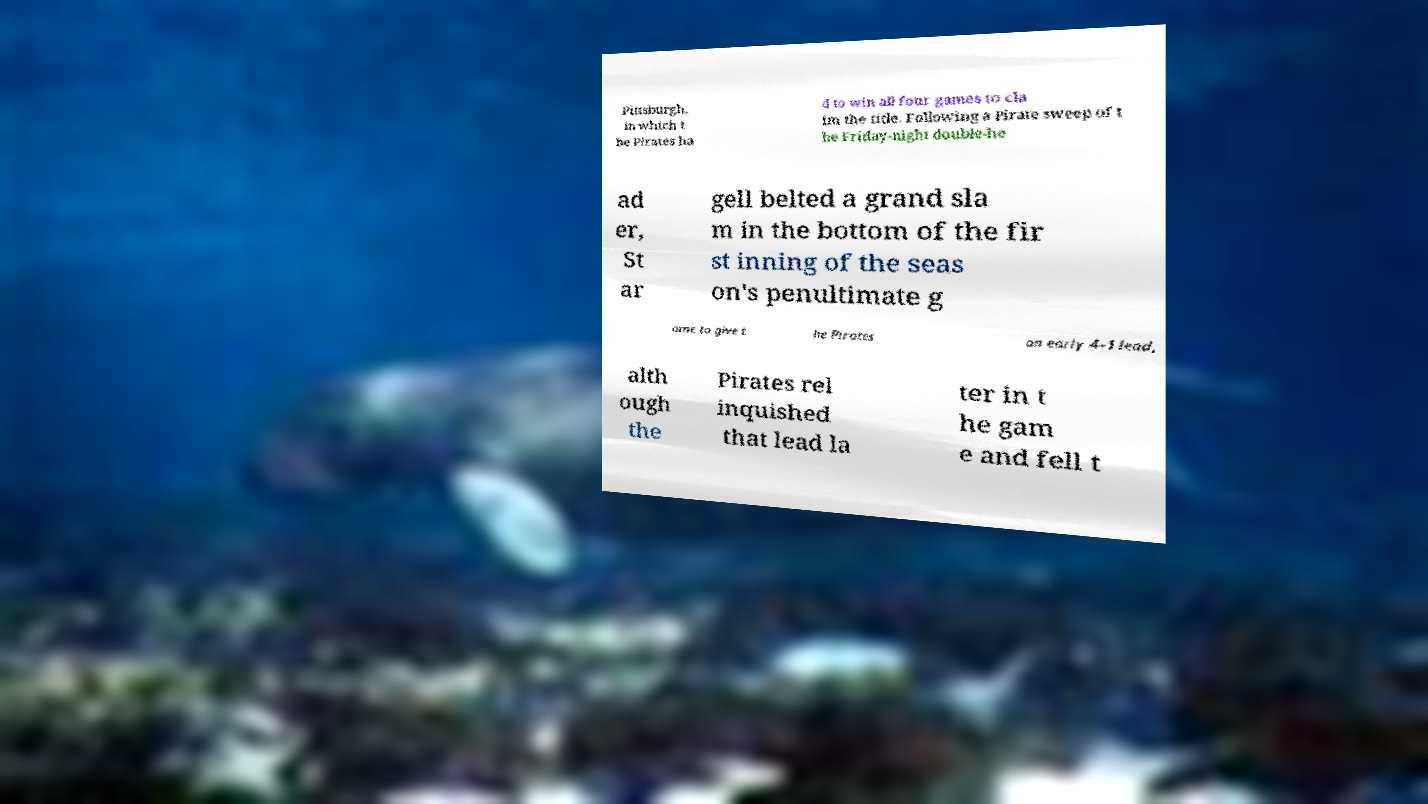There's text embedded in this image that I need extracted. Can you transcribe it verbatim? Pittsburgh, in which t he Pirates ha d to win all four games to cla im the title. Following a Pirate sweep of t he Friday-night double-he ad er, St ar gell belted a grand sla m in the bottom of the fir st inning of the seas on's penultimate g ame to give t he Pirates an early 4–1 lead, alth ough the Pirates rel inquished that lead la ter in t he gam e and fell t 